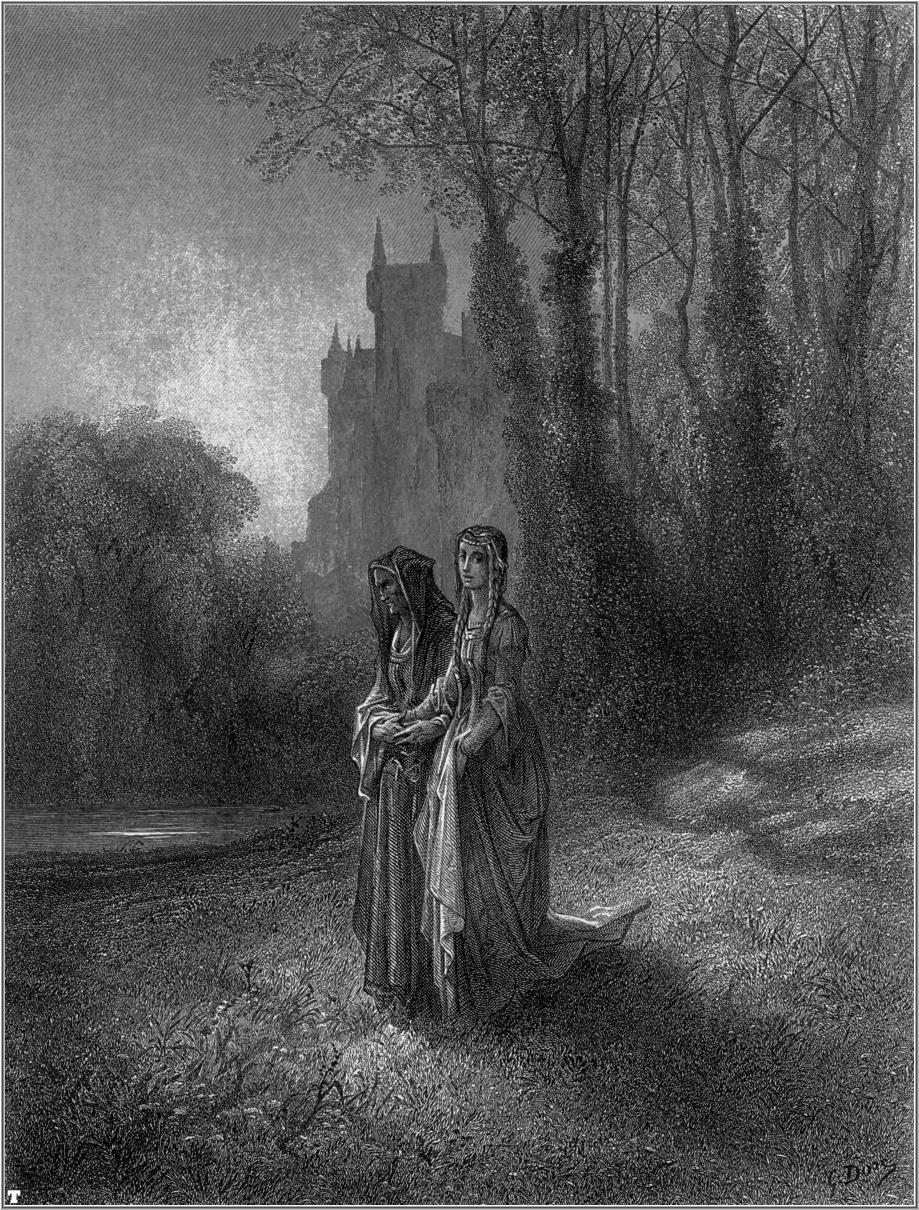What could the women be discussing as they walk through the forest? In this peaceful forest setting, the two women might be discussing the upcoming festival that is to be held at the castle. They could be talking about their preparations, the dresses they will wear, and the roles they will play in the festivities. Perhaps they are sharing memories of past festivals, reminiscing about the dances and the laughter shared with friends and family. Alternatively, they might be exchanging thoughts about recent events in the village, offering each other support and advice. Their conversation could be a moment of solace and connection in the midst of their daily routines, reflecting the deep bond they share. 